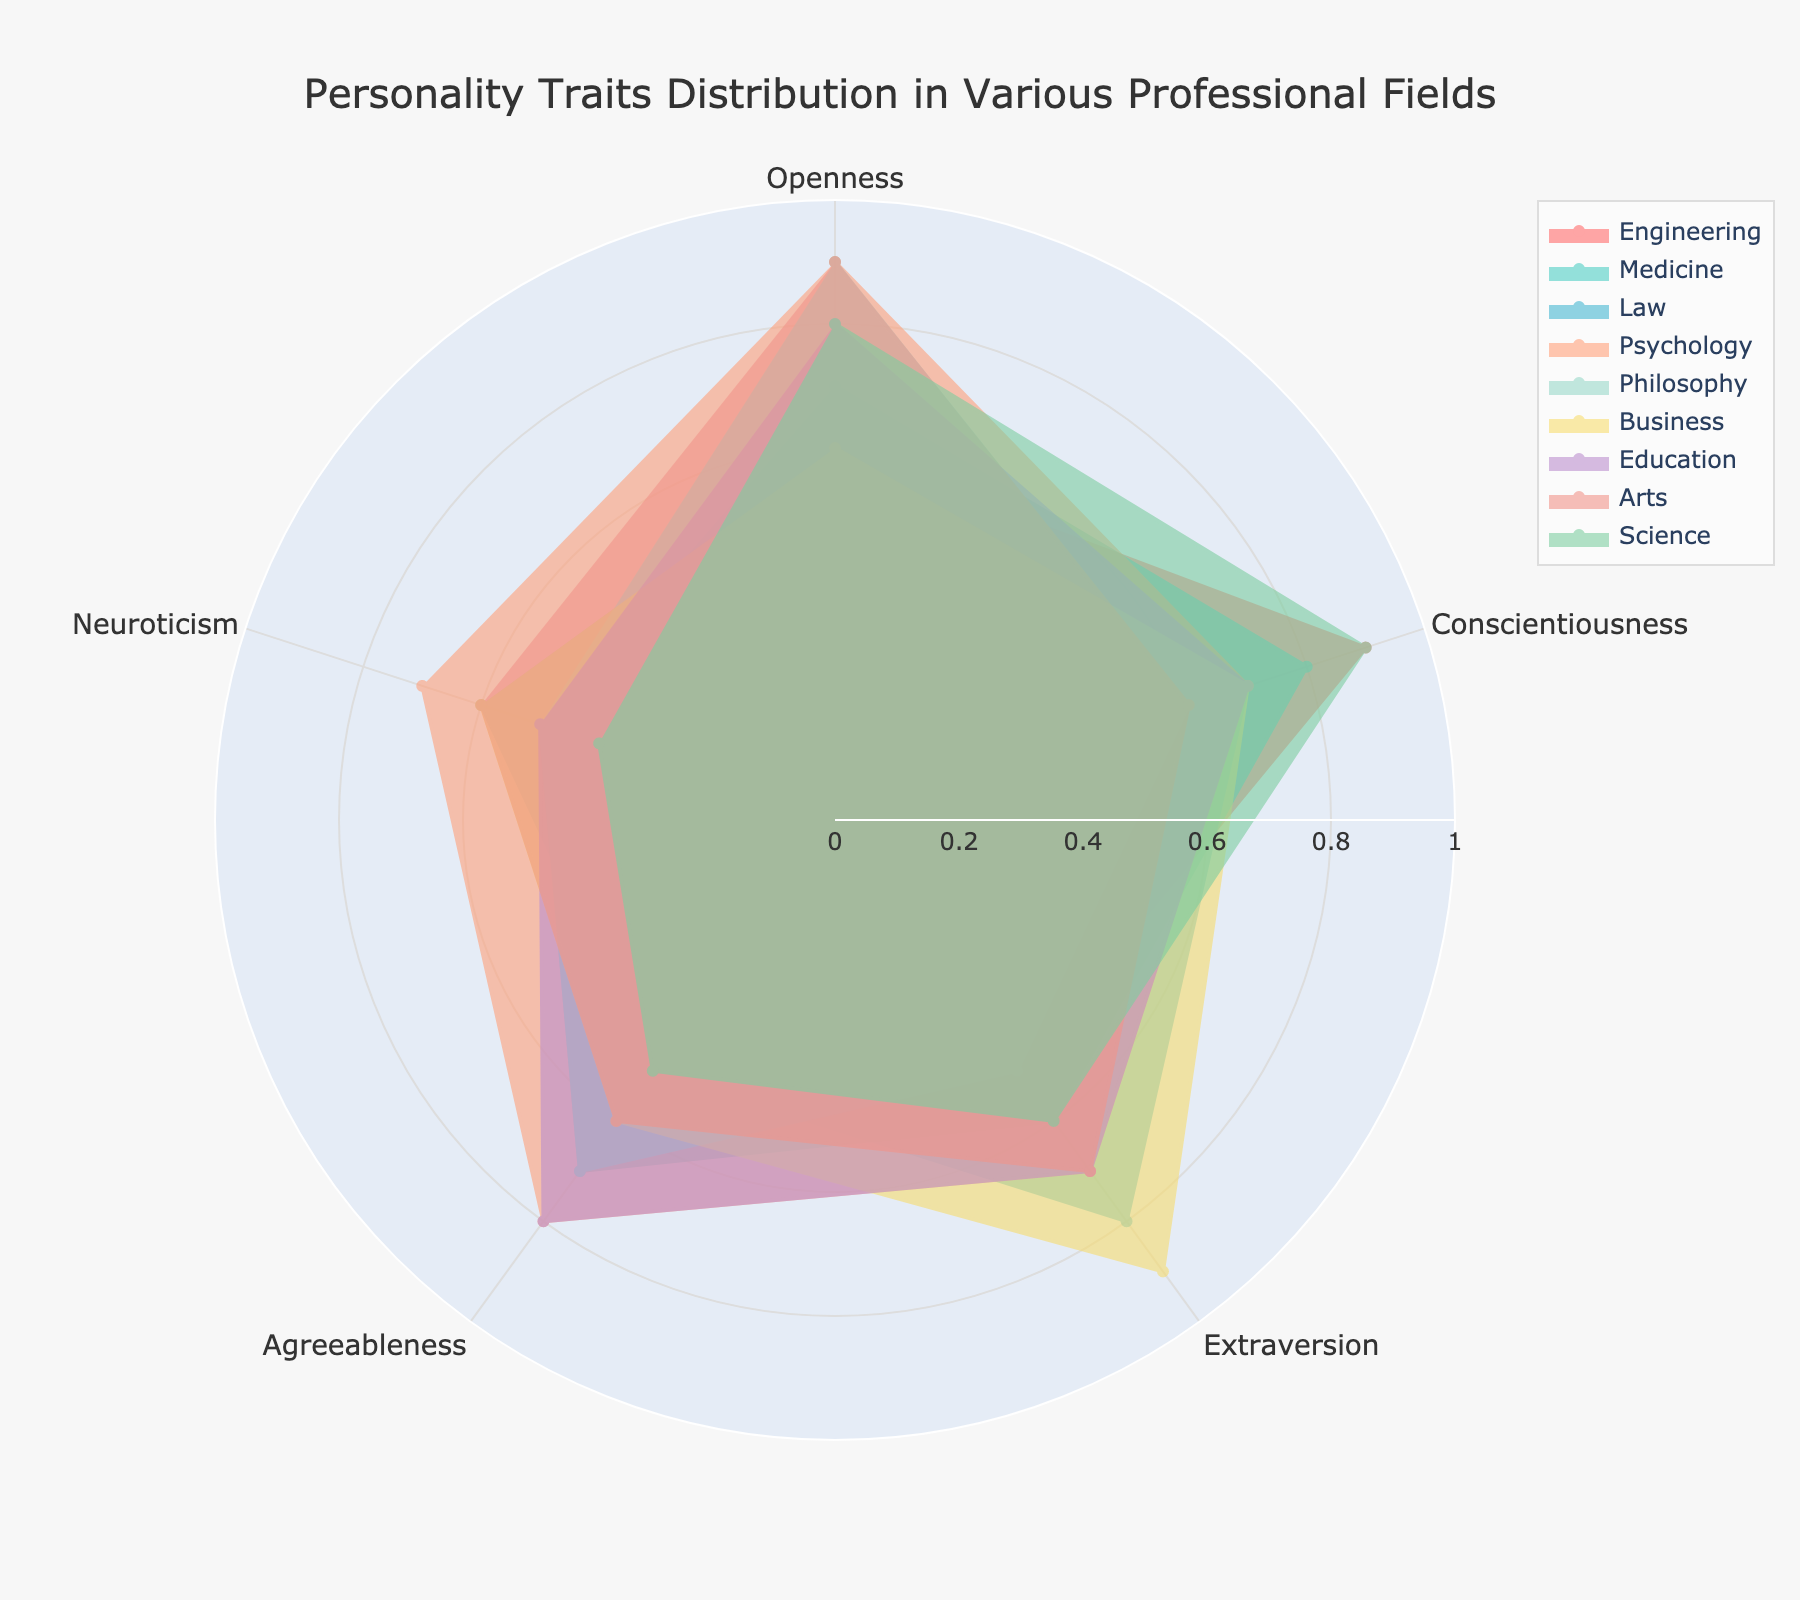What is the title of the chart? The title of a chart is usually found at the top and provides an overview of the data being visualized. This particular chart has the title that describes what it represents.
Answer: Personality Traits Distribution in Various Professional Fields Which profession has the highest score for Openness? To answer this, look at the Openness trait's axis and check which profession's plot reaches the maximum point along this axis. Both Psychology, Philosophy, and Arts show a score of 0.9, which is the highest.
Answer: Psychology, Philosophy, Arts How many professions have Agreeableness scores of 0.8? Check the Agreeableness axis and count how many profession plots intersect with the 0.8 mark. Education and Psychology both show a score of 0.8.
Answer: Two Which profession has the lowest score in Neuroticism? Scan the Neuroticism axis and identify the profession whose plot is closest to the center, corresponding to the lowest value. Engineering and Science both score 0.4, the lowest.
Answer: Engineering, Science Compare Conscientiousness between Engineering and Medicine. Which profession scores higher? Check the Conscientiousness axis and compare the positions of the plots for Engineering and Medicine along this axis. Engineering has a score of 0.9, higher than Medicine's 0.8.
Answer: Engineering Do any professions have identical scores in at least two traits? Identify the traits' axes and look for professions whose plots have overlapping points across at least two traits. Psychology shares 0.7 in both Conscientiousness and Extraversion.
Answer: Yes What is the average Extraversion score for Philosophy, Business, and Arts combined? Add the Extraversion scores for Philosophy (0.5), Business (0.9), and Arts (0.7), then divide by 3. The average is (0.5 + 0.9 + 0.7) / 3.
Answer: 0.7 Which profession has the highest overall balance across all five personality traits? Look for the profession with the most evenly distributed points along all axes, indicating less deviation among the traits. Medicine and Education both have balanced traits, but Education might be marginally more balanced.
Answer: Education Is the Agreeableness score for Law greater than that for Engineering? Check the Agreeableness axis and compare the points for Law and Engineering. Law has 0.5, while Engineering has 0.4.
Answer: Yes If we consider a professional field balanced if no trait is less than 0.5, which fields could be considered balanced? Check each profession and ensure each score is at least 0.5. Law, Medicine, Business, and Psychology meet this criterion.
Answer: Law, Medicine, Business, Psychology 